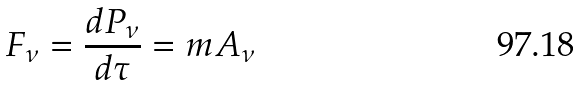<formula> <loc_0><loc_0><loc_500><loc_500>F _ { \nu } = { \frac { d P _ { \nu } } { d \tau } } = m A _ { \nu }</formula> 